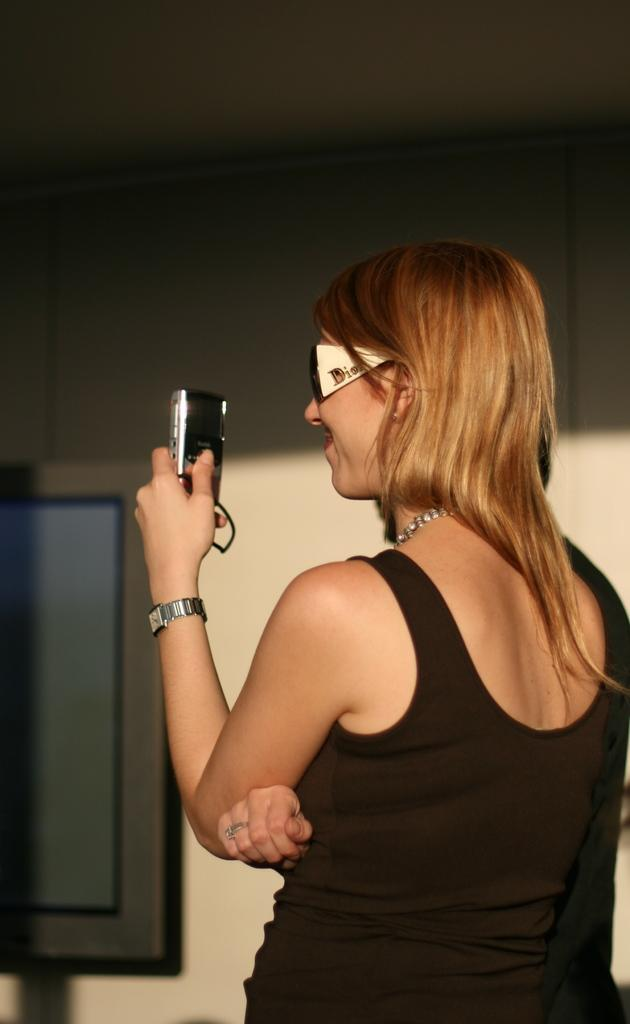Who is present in the image? There is a woman in the image. What is the woman doing in the image? The woman is standing in the image. What accessory is the woman wearing? The woman is wearing glasses (specs) in the image. What is the woman holding in the image? The woman is holding a camera in the image. What can be seen in the background of the image? There is a wall and a window door in the background of the image. What type of cakes can be seen in the image? There are no cakes present in the image. Is the woman driving a vehicle in the image? There is no vehicle or driving activity depicted in the image. --- Facts: 1. There is a car in the image. 2. The car is red. 3. The car has four wheels. 4. There is a road in the image. 5. The road is paved. Absurd Topics: parrot, ocean, dance Conversation: What is the main subject of the image? The main subject of the image is a car. What color is the car? The car is red. How many wheels does the car have? The car has four wheels. What can be seen in the background of the image? There is a road in the image. What type of road is visible in the image? The road is paved. Reasoning: Let's think step by step in order to produce the conversation. We start by identifying the main subject in the image, which is the car. Then, we expand the conversation to include the car's color and the number of wheels it has. We also describe the background of the image based on the provided facts. Each question is designed to elicit a specific detail about the image that is known from the provided facts. Absurd Question/Answer: Can you see a parrot flying over the car in the image? There is no parrot or flying activity depicted in the image. Is the car parked near the ocean in the image? There is no ocean or any body of water visible in the image. 